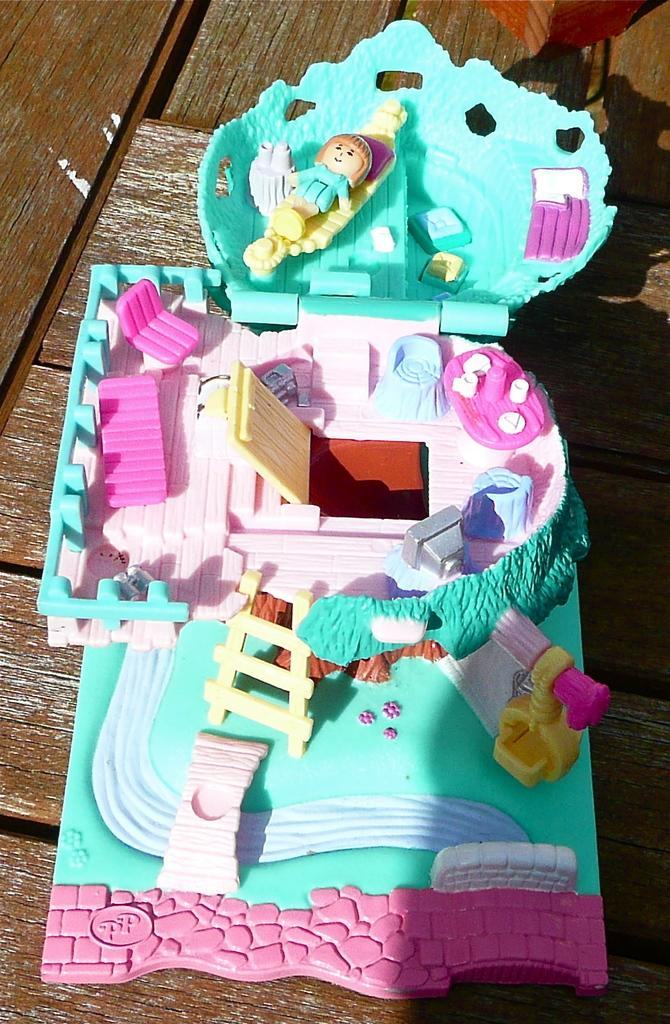What is the main subject of the image? There is a miniature in the image. Where is the miniature located? The miniature is on the floor. What material is the floor made of? The floor is made up of wood. How many pins are holding the miniature in place on the floor? There are no pins mentioned or visible in the image; the miniature is simply on the floor. 